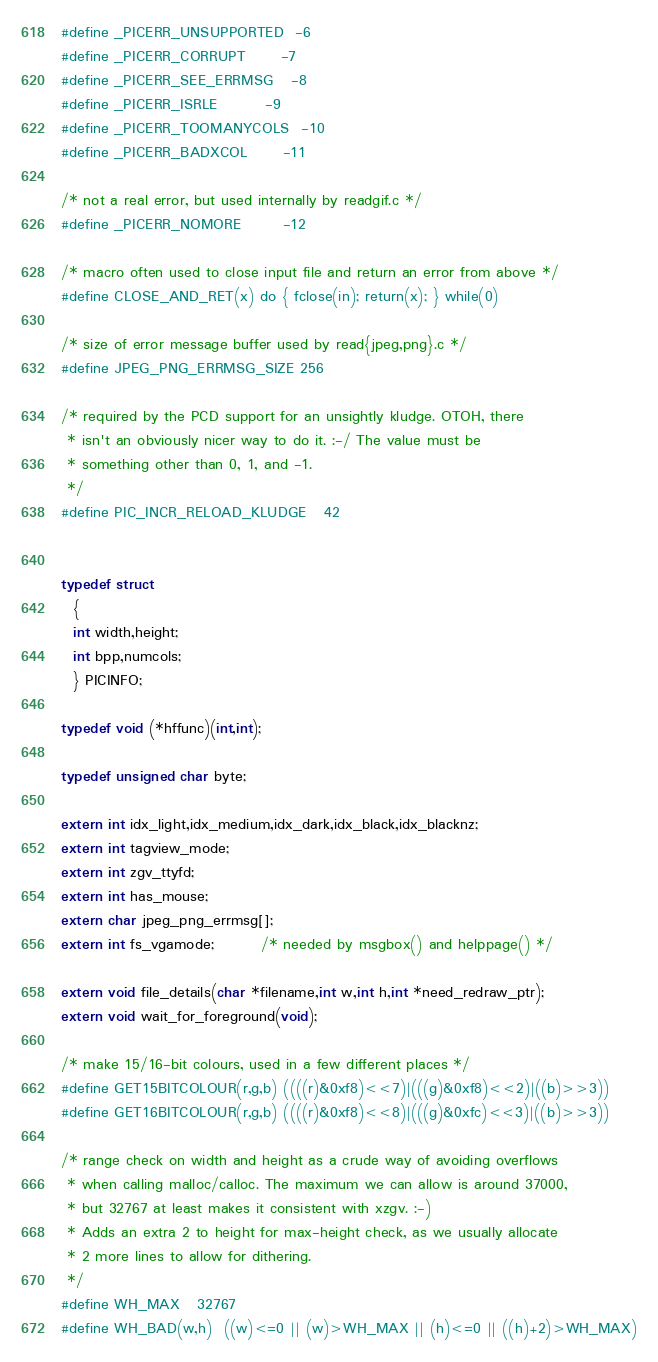<code> <loc_0><loc_0><loc_500><loc_500><_C_>#define _PICERR_UNSUPPORTED	-6
#define _PICERR_CORRUPT		-7
#define _PICERR_SEE_ERRMSG	-8
#define _PICERR_ISRLE		-9
#define _PICERR_TOOMANYCOLS	-10
#define _PICERR_BADXCOL		-11

/* not a real error, but used internally by readgif.c */
#define _PICERR_NOMORE		-12

/* macro often used to close input file and return an error from above */
#define CLOSE_AND_RET(x)	do { fclose(in); return(x); } while(0)

/* size of error message buffer used by read{jpeg,png}.c */
#define JPEG_PNG_ERRMSG_SIZE	256

/* required by the PCD support for an unsightly kludge. OTOH, there
 * isn't an obviously nicer way to do it. :-/ The value must be
 * something other than 0, 1, and -1.
 */
#define PIC_INCR_RELOAD_KLUDGE	42


typedef struct
  {
  int width,height;
  int bpp,numcols;
  } PICINFO;

typedef void (*hffunc)(int,int);

typedef unsigned char byte;

extern int idx_light,idx_medium,idx_dark,idx_black,idx_blacknz;
extern int tagview_mode;
extern int zgv_ttyfd;
extern int has_mouse;
extern char jpeg_png_errmsg[];
extern int fs_vgamode;		/* needed by msgbox() and helppage() */

extern void file_details(char *filename,int w,int h,int *need_redraw_ptr);
extern void wait_for_foreground(void);

/* make 15/16-bit colours, used in a few different places */
#define GET15BITCOLOUR(r,g,b) ((((r)&0xf8)<<7)|(((g)&0xf8)<<2)|((b)>>3))
#define GET16BITCOLOUR(r,g,b) ((((r)&0xf8)<<8)|(((g)&0xfc)<<3)|((b)>>3))

/* range check on width and height as a crude way of avoiding overflows
 * when calling malloc/calloc. The maximum we can allow is around 37000,
 * but 32767 at least makes it consistent with xzgv. :-)
 * Adds an extra 2 to height for max-height check, as we usually allocate
 * 2 more lines to allow for dithering.
 */
#define WH_MAX	32767
#define WH_BAD(w,h)	((w)<=0 || (w)>WH_MAX || (h)<=0 || ((h)+2)>WH_MAX)
</code> 